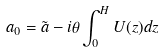<formula> <loc_0><loc_0><loc_500><loc_500>a _ { 0 } = \tilde { a } - i \theta \int _ { 0 } ^ { H } U ( z ) d z</formula> 